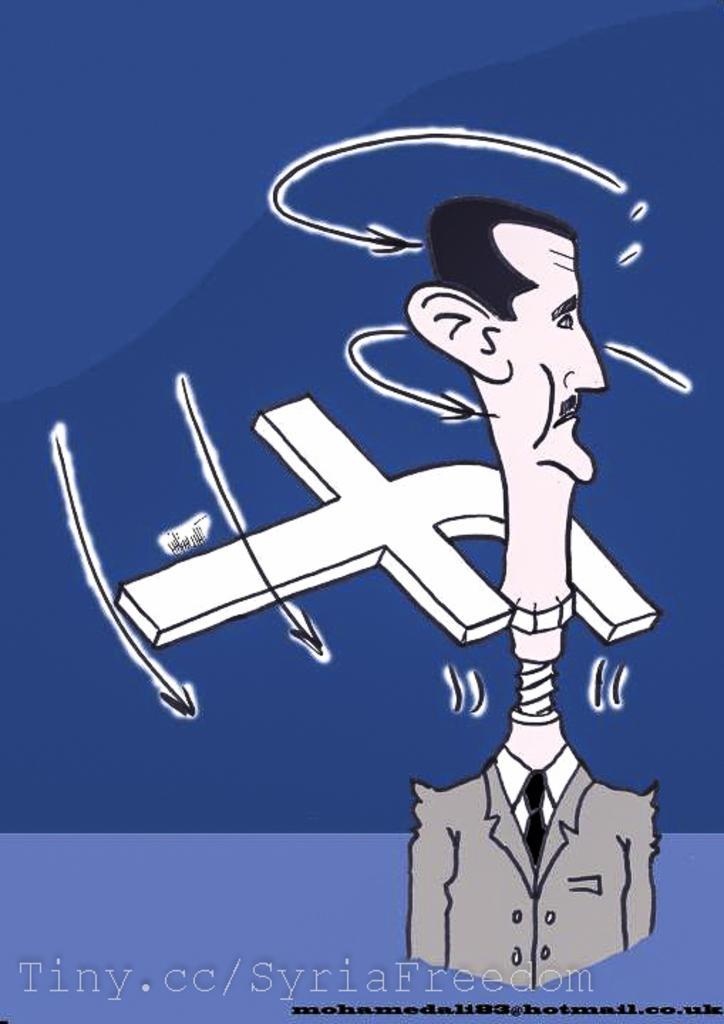Could you give a brief overview of what you see in this image? In this image I can see a cartoon image of person and letter and text and cloth visible. 